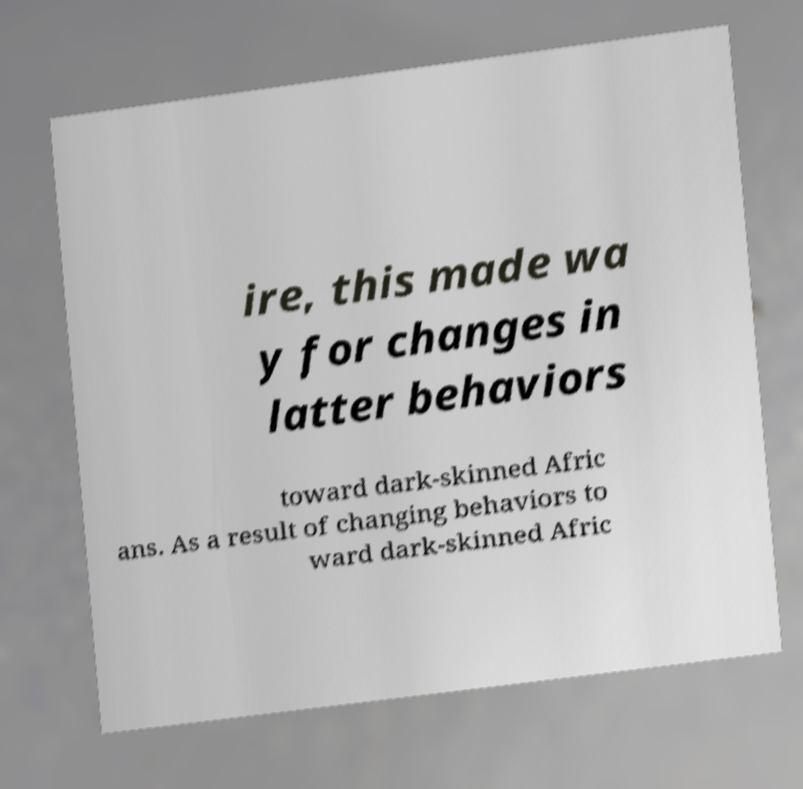There's text embedded in this image that I need extracted. Can you transcribe it verbatim? ire, this made wa y for changes in latter behaviors toward dark-skinned Afric ans. As a result of changing behaviors to ward dark-skinned Afric 